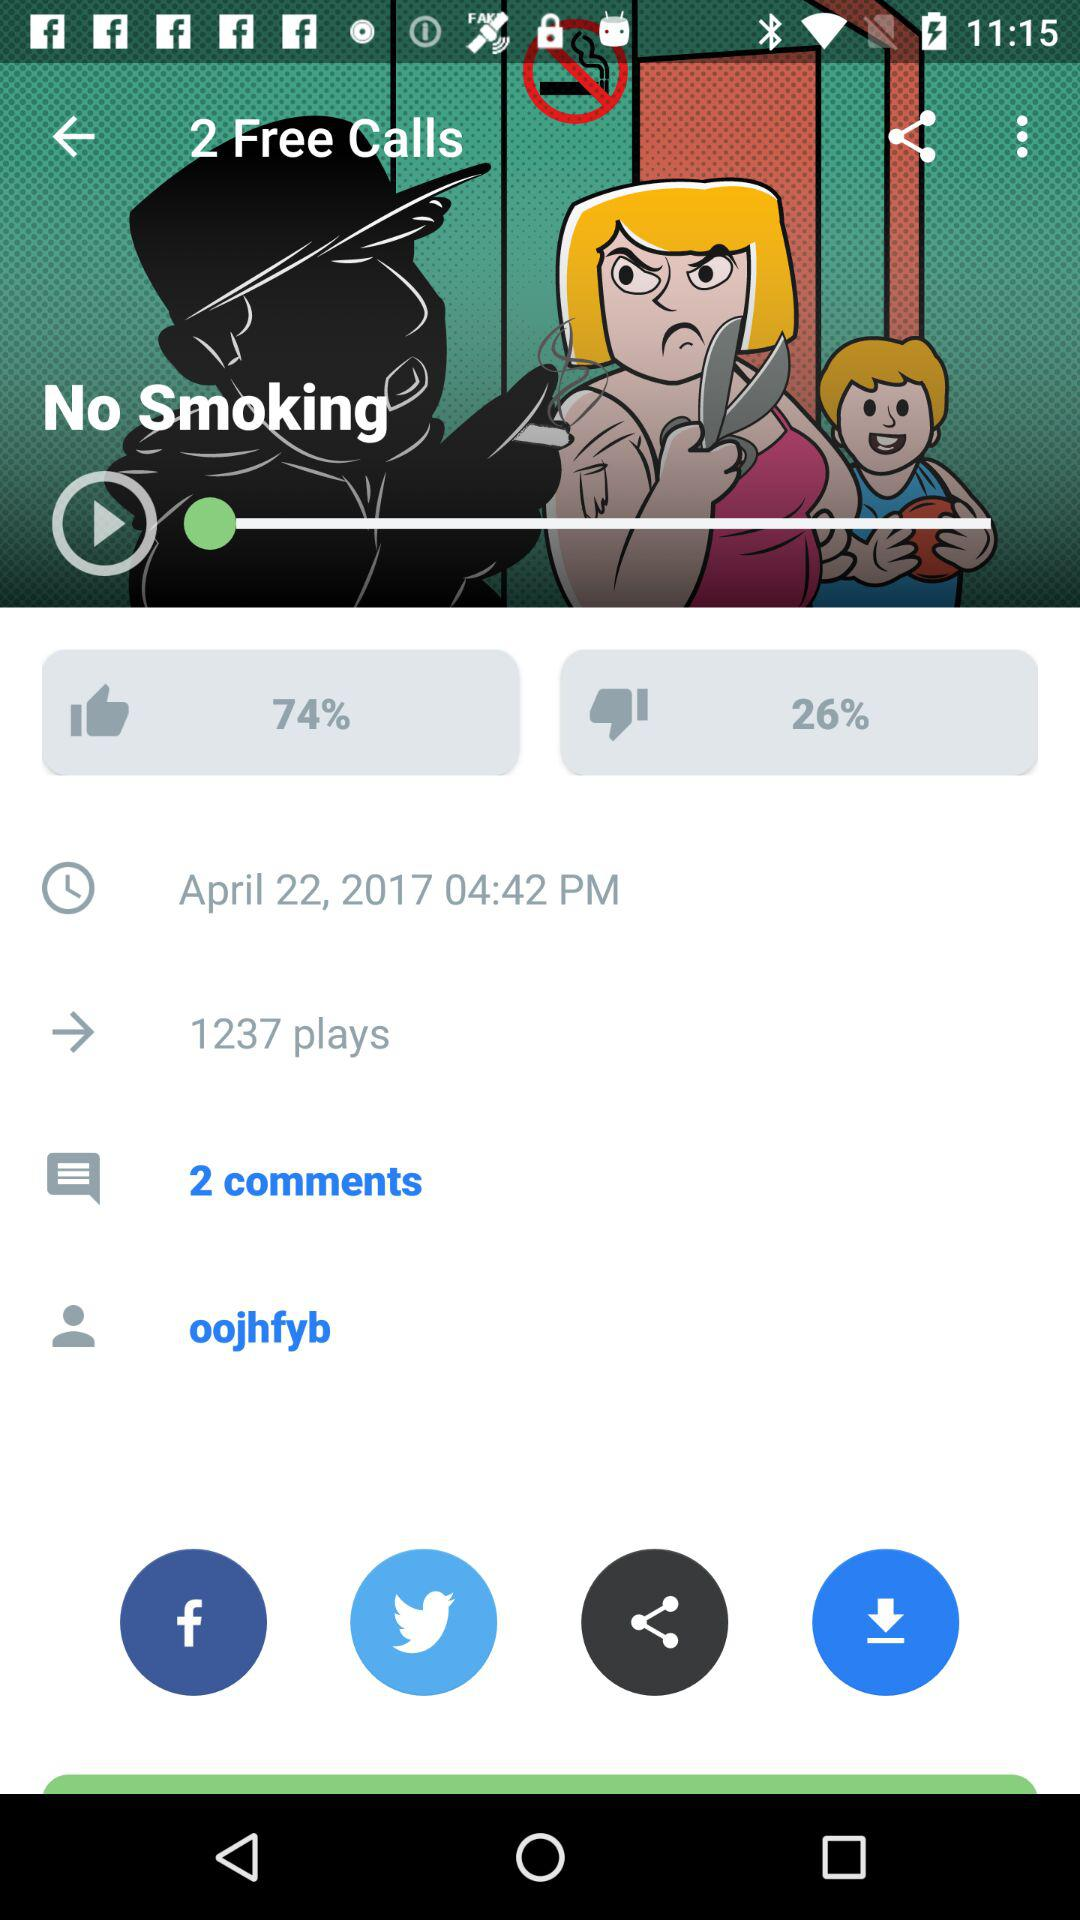What percentage of people have liked "No Smoking"? The percentage of people who have liked "No Smoking" is 74. 